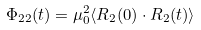<formula> <loc_0><loc_0><loc_500><loc_500>\Phi _ { 2 2 } ( t ) = \mu _ { 0 } ^ { 2 } \langle { R } _ { 2 } ( 0 ) \cdot { R } _ { 2 } ( t ) \rangle</formula> 